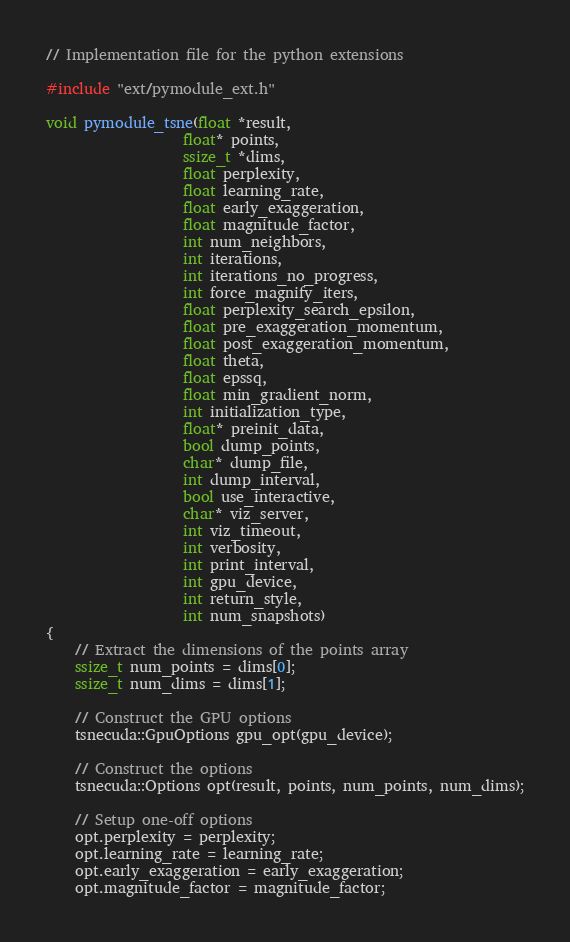Convert code to text. <code><loc_0><loc_0><loc_500><loc_500><_Cuda_>
// Implementation file for the python extensions

#include "ext/pymodule_ext.h"

void pymodule_tsne(float *result,
                   float* points,
                   ssize_t *dims,
                   float perplexity,
                   float learning_rate,
                   float early_exaggeration,
                   float magnitude_factor,
                   int num_neighbors,
                   int iterations,
                   int iterations_no_progress,
                   int force_magnify_iters,
                   float perplexity_search_epsilon,
                   float pre_exaggeration_momentum,
                   float post_exaggeration_momentum,
                   float theta,
                   float epssq,
                   float min_gradient_norm,
                   int initialization_type,
                   float* preinit_data,
                   bool dump_points,
                   char* dump_file,
                   int dump_interval,
                   bool use_interactive,
                   char* viz_server,
                   int viz_timeout,
                   int verbosity,
                   int print_interval,
                   int gpu_device,
                   int return_style,
                   int num_snapshots)
{
    // Extract the dimensions of the points array
    ssize_t num_points = dims[0];
    ssize_t num_dims = dims[1];

    // Construct the GPU options
    tsnecuda::GpuOptions gpu_opt(gpu_device);

    // Construct the options
    tsnecuda::Options opt(result, points, num_points, num_dims);

    // Setup one-off options
    opt.perplexity = perplexity;
    opt.learning_rate = learning_rate;
    opt.early_exaggeration = early_exaggeration;
    opt.magnitude_factor = magnitude_factor;</code> 